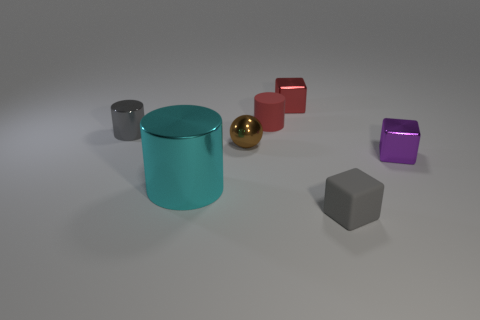What is the tiny gray cylinder made of?
Make the answer very short. Metal. What number of things are either metal cylinders that are behind the brown metallic ball or tiny metal things that are to the right of the big cyan cylinder?
Make the answer very short. 4. How many other things are the same color as the tiny metallic cylinder?
Offer a very short reply. 1. There is a small brown shiny object; does it have the same shape as the metallic thing that is to the right of the small red metal thing?
Provide a succinct answer. No. Are there fewer spheres that are to the left of the tiny gray metal cylinder than large metallic cylinders right of the red matte object?
Provide a short and direct response. No. There is a small gray object that is the same shape as the cyan shiny object; what is its material?
Make the answer very short. Metal. Are there any other things that are made of the same material as the cyan object?
Keep it short and to the point. Yes. Is the color of the tiny metallic cylinder the same as the matte block?
Provide a succinct answer. Yes. What is the shape of the large object that is the same material as the red cube?
Your answer should be compact. Cylinder. What number of red shiny objects have the same shape as the small purple object?
Make the answer very short. 1. 